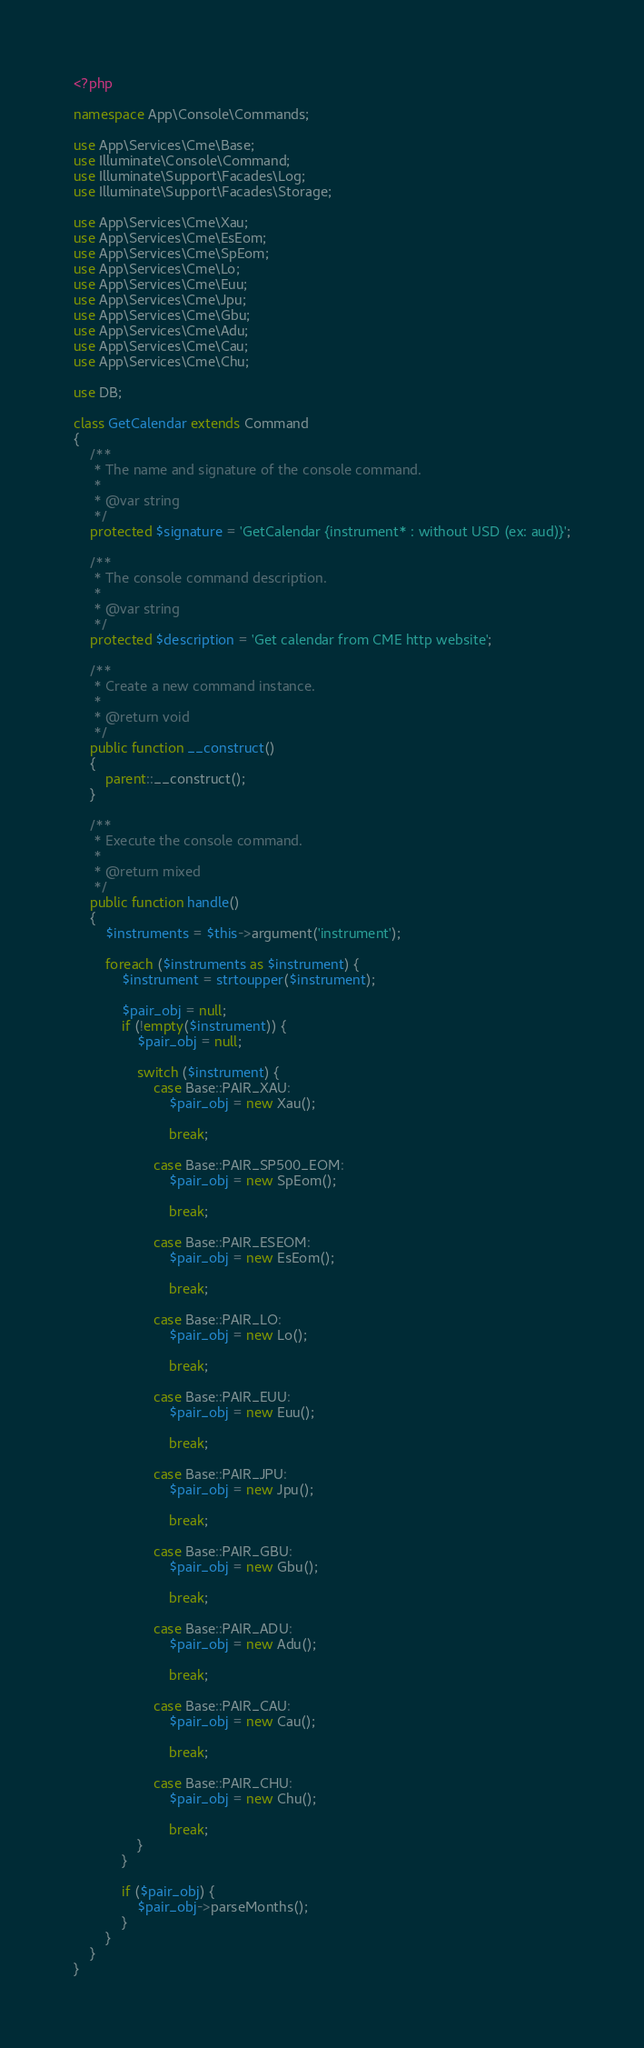<code> <loc_0><loc_0><loc_500><loc_500><_PHP_><?php

namespace App\Console\Commands;

use App\Services\Cme\Base;
use Illuminate\Console\Command;
use Illuminate\Support\Facades\Log;
use Illuminate\Support\Facades\Storage;

use App\Services\Cme\Xau;
use App\Services\Cme\EsEom;
use App\Services\Cme\SpEom;
use App\Services\Cme\Lo;
use App\Services\Cme\Euu;
use App\Services\Cme\Jpu;
use App\Services\Cme\Gbu;
use App\Services\Cme\Adu;
use App\Services\Cme\Cau;
use App\Services\Cme\Chu;

use DB;

class GetCalendar extends Command
{
    /**
     * The name and signature of the console command.
     *
     * @var string
     */
    protected $signature = 'GetCalendar {instrument* : without USD (ex: aud)}';

    /**
     * The console command description.
     *
     * @var string
     */
    protected $description = 'Get calendar from CME http website';

    /**
     * Create a new command instance.
     *
     * @return void
     */
    public function __construct()
    {
        parent::__construct();
    }

    /**
     * Execute the console command.
     *
     * @return mixed
     */
    public function handle()
    {
        $instruments = $this->argument('instrument');

        foreach ($instruments as $instrument) {
            $instrument = strtoupper($instrument);

            $pair_obj = null;
            if (!empty($instrument)) {
                $pair_obj = null;

                switch ($instrument) {
                    case Base::PAIR_XAU:
                        $pair_obj = new Xau();

                        break;

                    case Base::PAIR_SP500_EOM:
                        $pair_obj = new SpEom();

                        break;

                    case Base::PAIR_ESEOM:
                        $pair_obj = new EsEom();

                        break;

                    case Base::PAIR_LO:
                        $pair_obj = new Lo();

                        break;

                    case Base::PAIR_EUU:
                        $pair_obj = new Euu();

                        break;

                    case Base::PAIR_JPU:
                        $pair_obj = new Jpu();

                        break;

                    case Base::PAIR_GBU:
                        $pair_obj = new Gbu();

                        break;

                    case Base::PAIR_ADU:
                        $pair_obj = new Adu();

                        break;

                    case Base::PAIR_CAU:
                        $pair_obj = new Cau();

                        break;

                    case Base::PAIR_CHU:
                        $pair_obj = new Chu();

                        break;
                }
            }

            if ($pair_obj) {
                $pair_obj->parseMonths();
            }
        }
    }
}
</code> 